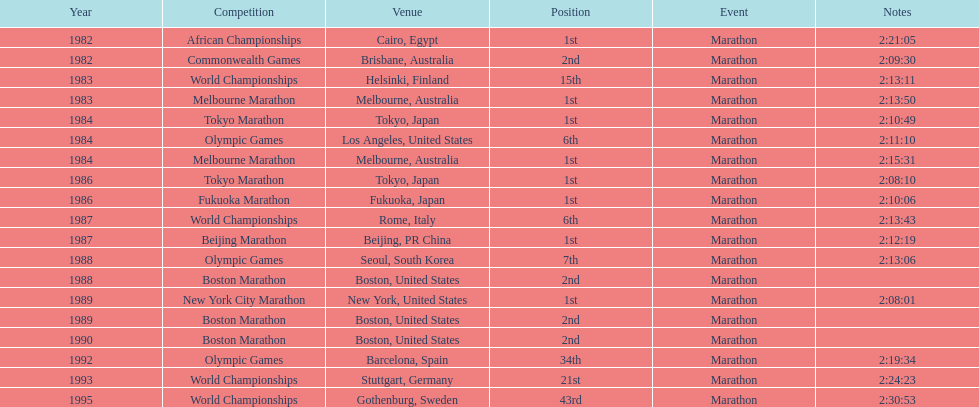Which competitive event is featured the most in this chart? World Championships. 